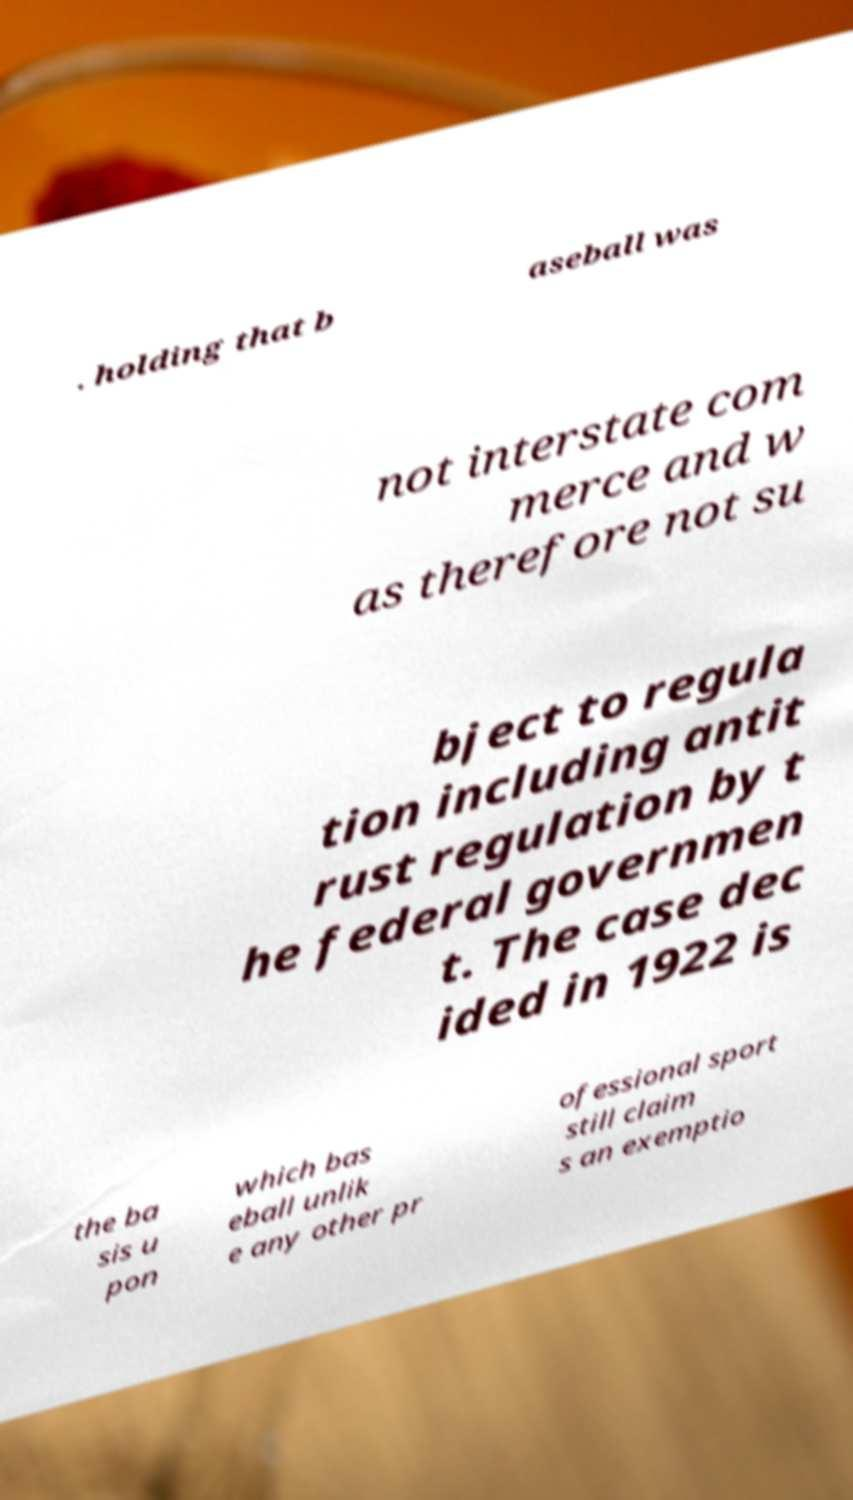Please read and relay the text visible in this image. What does it say? . holding that b aseball was not interstate com merce and w as therefore not su bject to regula tion including antit rust regulation by t he federal governmen t. The case dec ided in 1922 is the ba sis u pon which bas eball unlik e any other pr ofessional sport still claim s an exemptio 